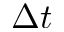<formula> <loc_0><loc_0><loc_500><loc_500>\Delta t</formula> 